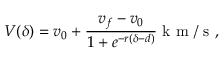<formula> <loc_0><loc_0><loc_500><loc_500>V ( \delta ) = v _ { 0 } + \frac { v _ { f } - v _ { 0 } } { 1 + e ^ { - r ( \delta - d ) } } k m / s ,</formula> 